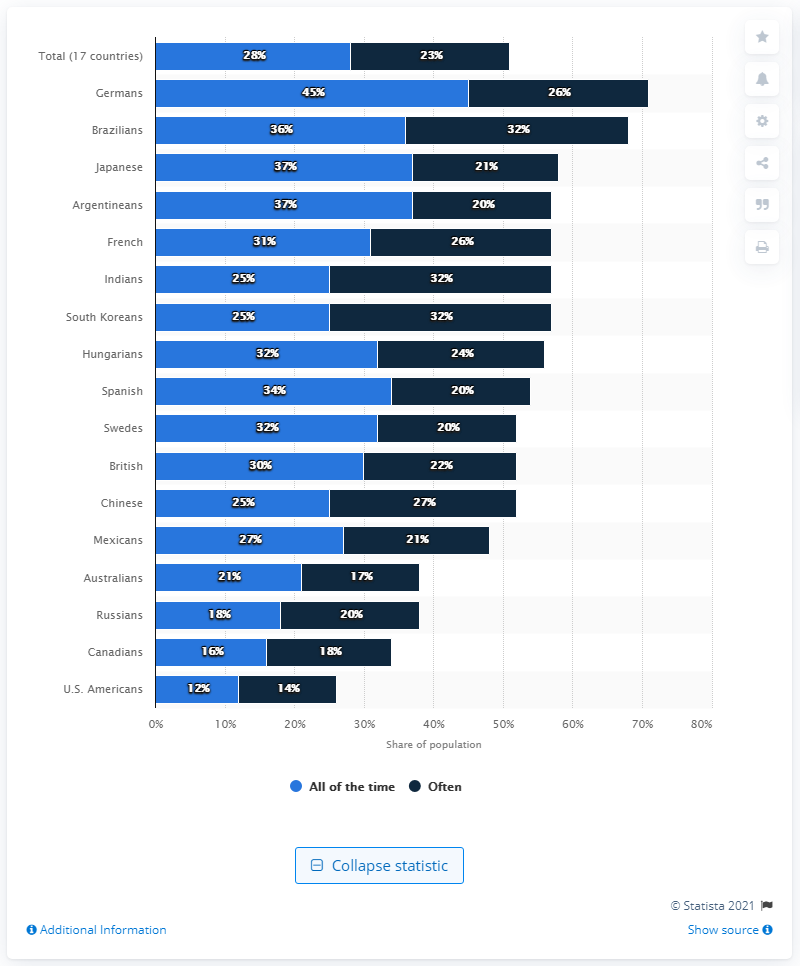Indicate a few pertinent items in this graphic. The chart shows 17 countries in total. The average between "all of the time" and "often" in Indians is approximately 28.5. 